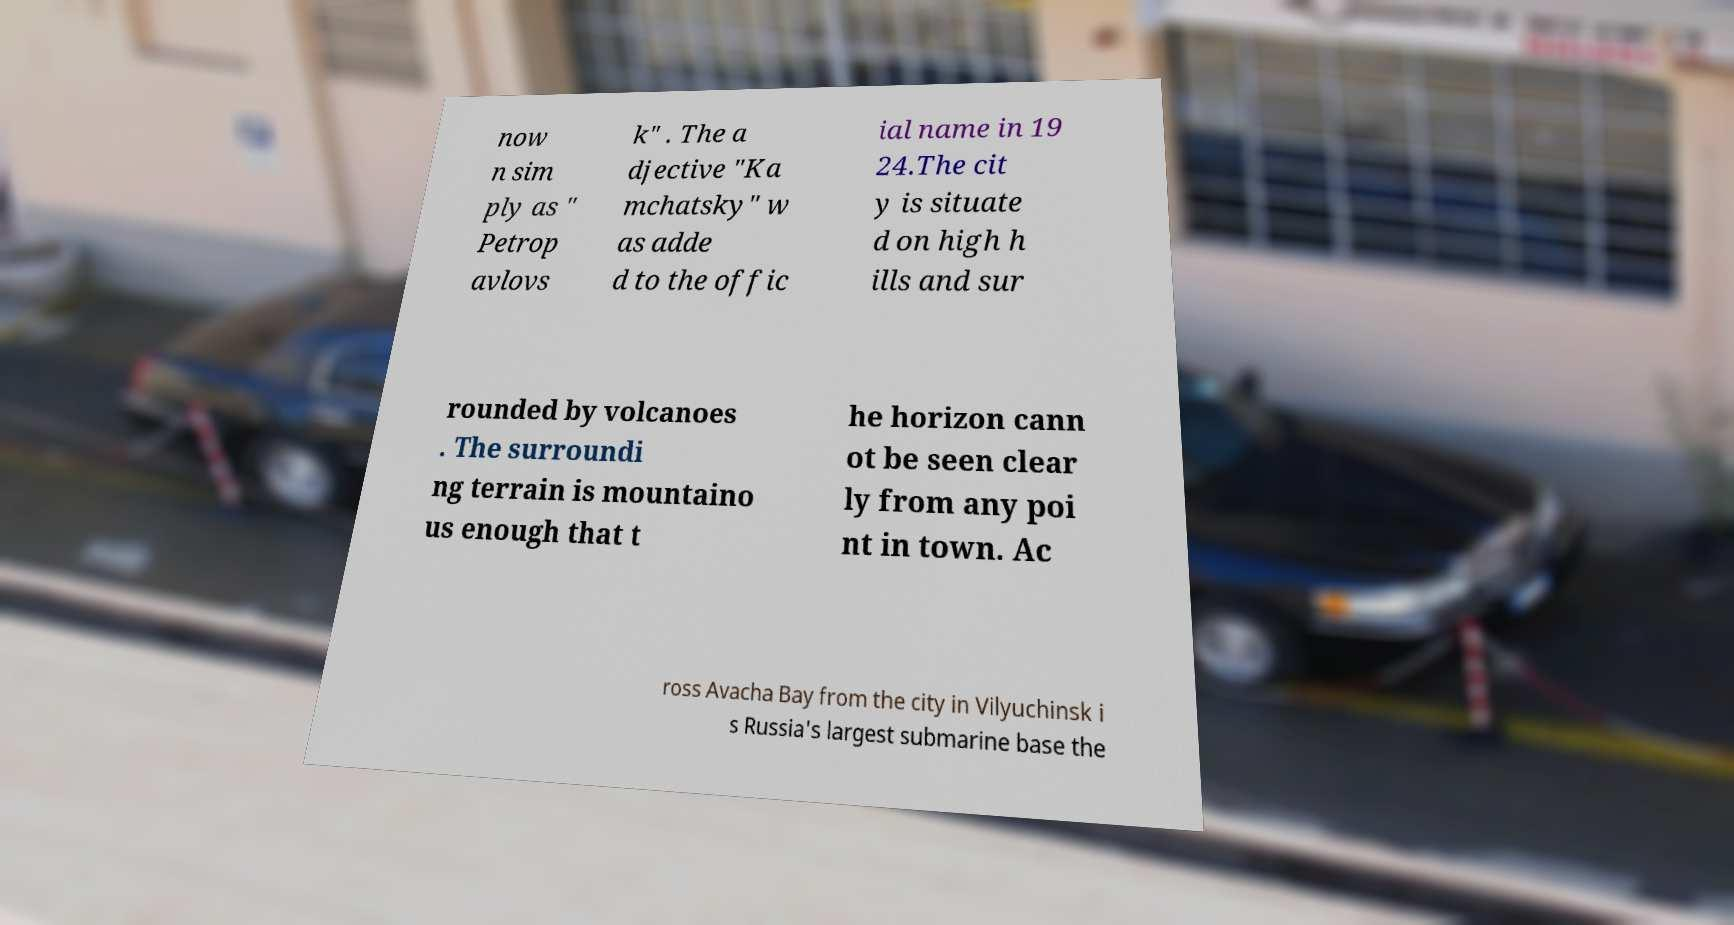I need the written content from this picture converted into text. Can you do that? now n sim ply as " Petrop avlovs k" . The a djective "Ka mchatsky" w as adde d to the offic ial name in 19 24.The cit y is situate d on high h ills and sur rounded by volcanoes . The surroundi ng terrain is mountaino us enough that t he horizon cann ot be seen clear ly from any poi nt in town. Ac ross Avacha Bay from the city in Vilyuchinsk i s Russia's largest submarine base the 